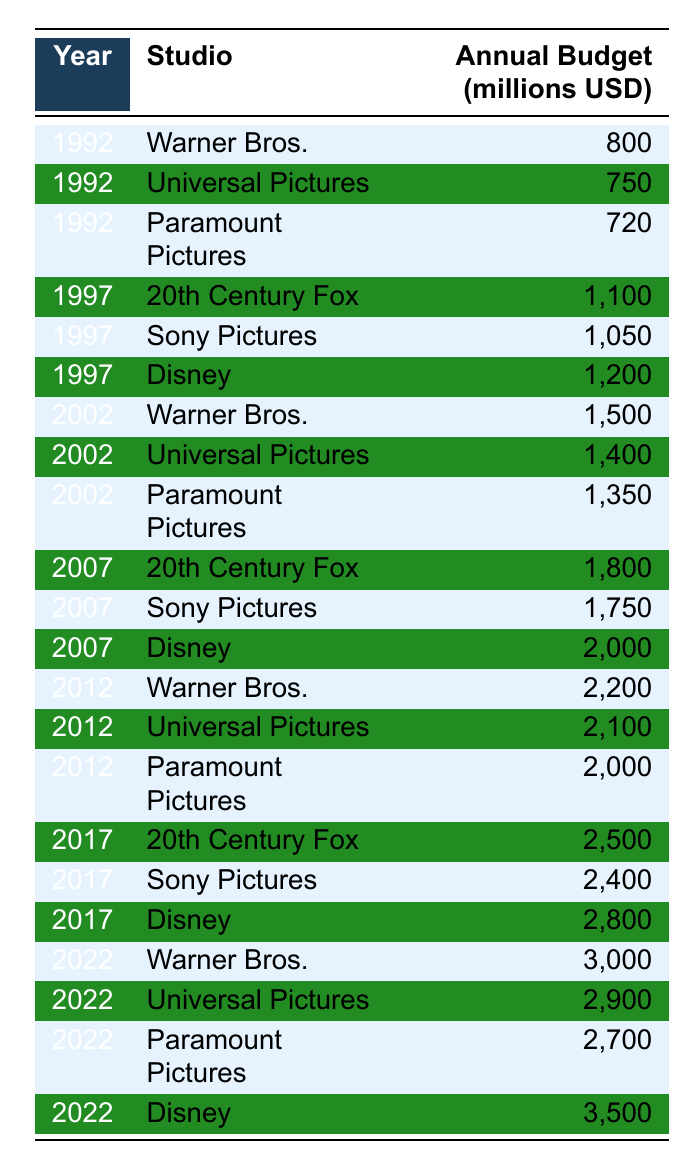What was the annual budget of Disney in 2022? In the row corresponding to the year 2022 for Disney, the budget is 3,500 million USD.
Answer: 3,500 million USD Which studio had the highest budget in 2017? In 2017, Disney had the highest budget of 2,800 million USD among the studios listed.
Answer: Disney What was the difference in budget between Warner Bros. in 2022 and Warner Bros. in 1992? The budget for Warner Bros. in 2022 is 3,000 million USD, and in 1992 it was 800 million USD. The difference is 3,000 - 800 = 2,200 million USD.
Answer: 2,200 million USD Which studios had an annual budget of over 2,000 million USD in 2012? The studios with budgets over 2,000 million USD in 2012 are Warner Bros. (2,200 million USD), Universal Pictures (2,100 million USD), and Paramount Pictures (2,000 million USD).
Answer: Warner Bros. and Universal Pictures What was the average annual budget for Universal Pictures across the years provided? The budgets for Universal Pictures are 750, 1,400, 2,100, 2,900 million USD over the years presented. Adding these gives 750 + 1,400 + 2,100 + 2,900 = 8,150 million USD. Dividing by 4 (the number of entries) gives an average of 8,150 / 4 = 2,037.5 million USD.
Answer: 2,037.5 million USD Did 20th Century Fox ever have a higher budget than Sony Pictures in the same year? Yes, in 2017, 20th Century Fox had a budget of 2,500 million USD, which is higher than Sony Pictures' 2,400 million USD for the same year.
Answer: Yes Which studio showed the highest growth in budget from 1992 to 2022? For Warner Bros., the budget increased from 800 million USD in 1992 to 3,000 million USD in 2022, a growth of 2,200 million USD. For other studios, similar calculations reveal that Warner Bros. had the highest absolute growth in budget.
Answer: Warner Bros 